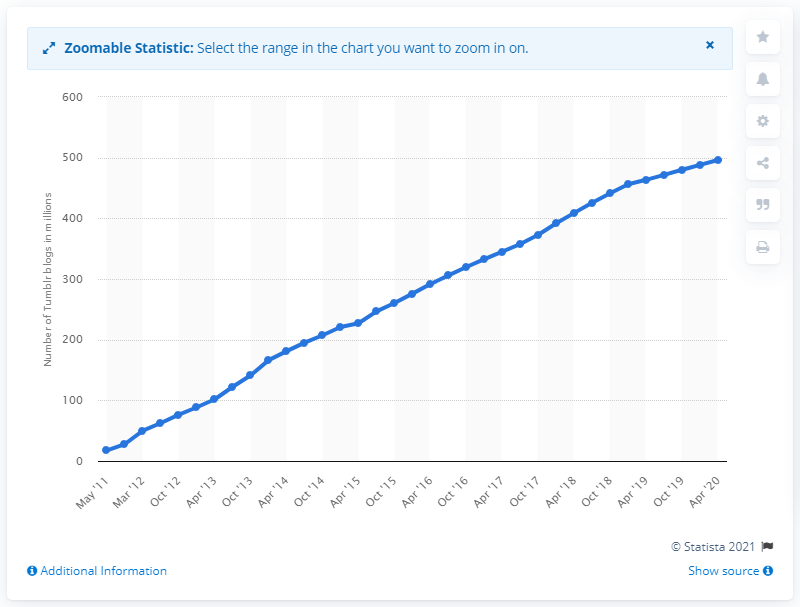Highlight a few significant elements in this photo. Tumblr.com had approximately 463.5 blog accounts in May 2011. In May 2011, Tumblr had 496.1 blog accounts, and by April 2020, the number of blog accounts had increased to 496.1. 